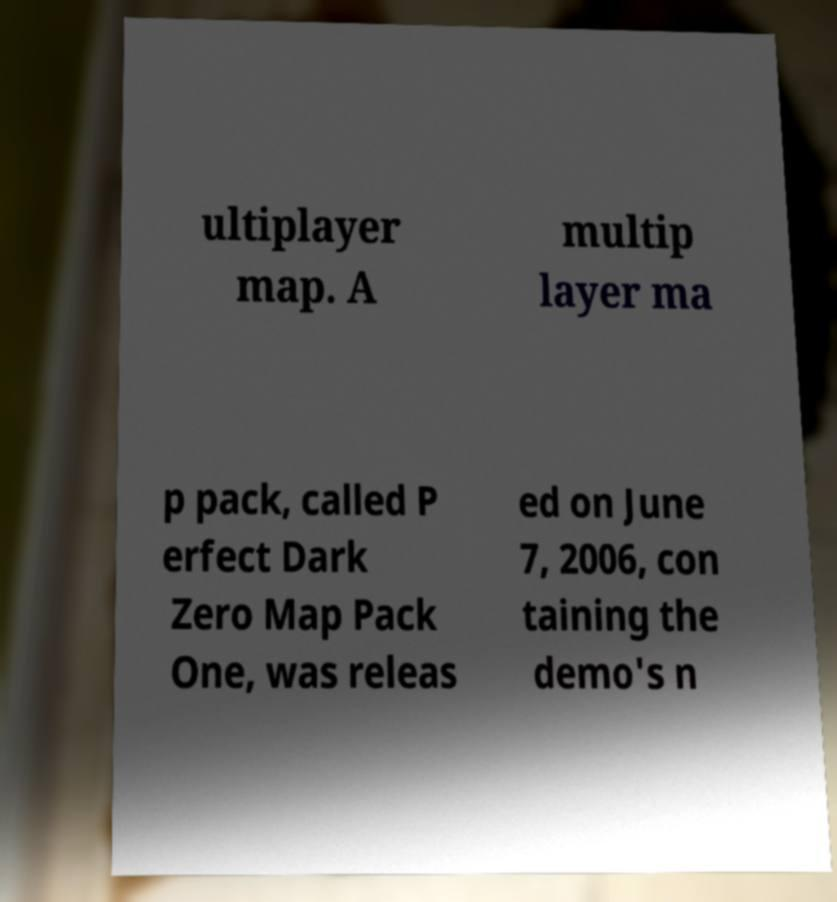What messages or text are displayed in this image? I need them in a readable, typed format. ultiplayer map. A multip layer ma p pack, called P erfect Dark Zero Map Pack One, was releas ed on June 7, 2006, con taining the demo's n 